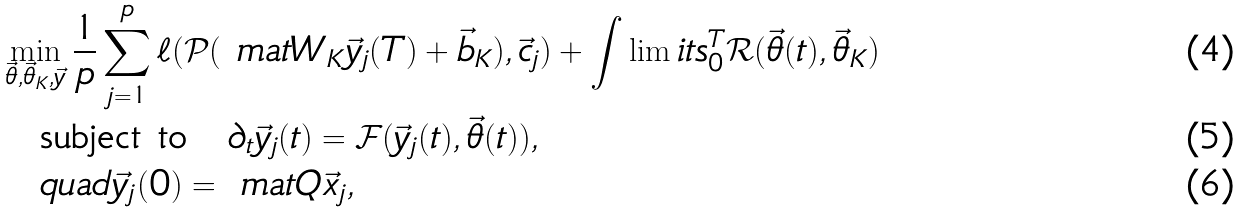Convert formula to latex. <formula><loc_0><loc_0><loc_500><loc_500>& \min _ { \vec { \theta } , \vec { \theta } _ { K } , \vec { y } } \frac { 1 } { p } \sum _ { j = 1 } ^ { p } \ell ( \mathcal { P } ( \ m a t { W } _ { K } \vec { y } _ { j } ( T ) + \vec { b } _ { K } ) , \vec { c } _ { j } ) + \int \lim i t s _ { 0 } ^ { T } \mathcal { R } ( \vec { \theta } ( t ) , \vec { \theta } _ { K } ) \\ & \quad \text {subject to} \quad \partial _ { t } \vec { y } _ { j } ( t ) = \mathcal { F } ( \vec { y } _ { j } ( t ) , \vec { \theta } ( t ) ) , \\ & \quad q u a d \vec { y } _ { j } ( 0 ) = \ m a t { Q } \vec { x } _ { j } ,</formula> 